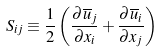<formula> <loc_0><loc_0><loc_500><loc_500>S _ { i j } \equiv \frac { 1 } { 2 } \left ( \frac { \partial \overline { u } _ { j } } { \partial x _ { i } } + \frac { \partial \overline { u } _ { i } } { \partial x _ { j } } \right )</formula> 